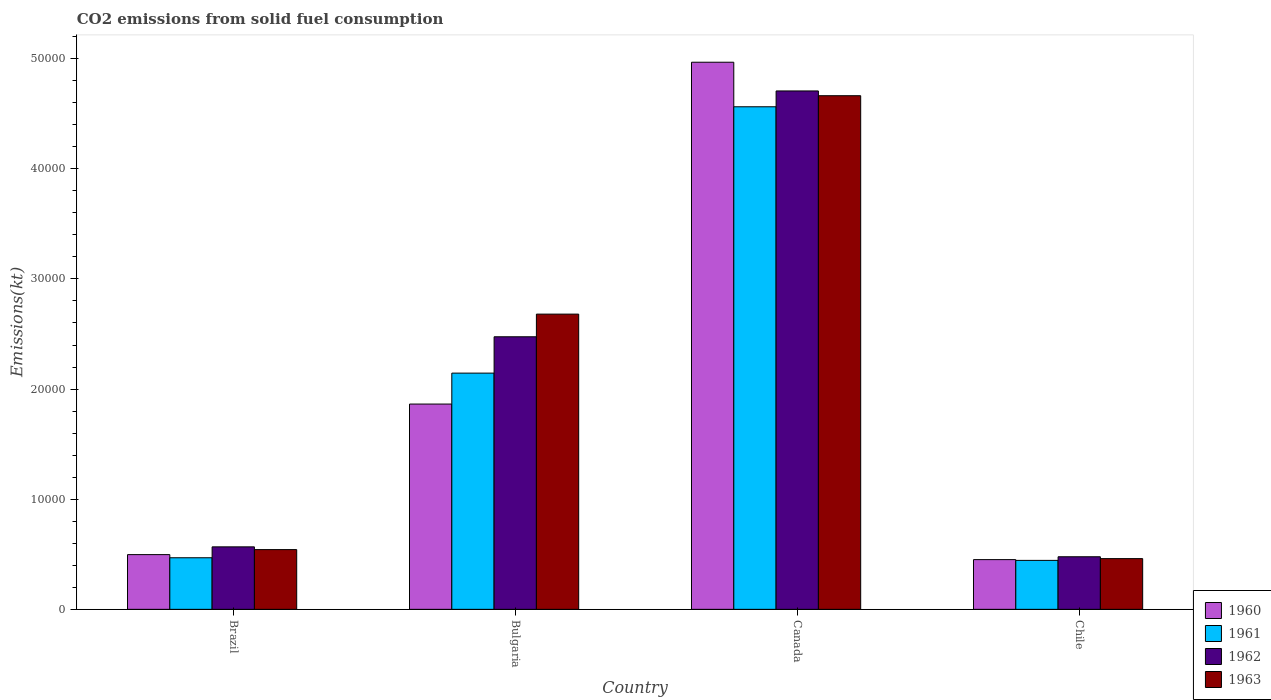Are the number of bars on each tick of the X-axis equal?
Keep it short and to the point. Yes. How many bars are there on the 4th tick from the right?
Your response must be concise. 4. What is the amount of CO2 emitted in 1960 in Canada?
Offer a terse response. 4.97e+04. Across all countries, what is the maximum amount of CO2 emitted in 1962?
Your answer should be very brief. 4.71e+04. Across all countries, what is the minimum amount of CO2 emitted in 1960?
Make the answer very short. 4514.08. In which country was the amount of CO2 emitted in 1961 maximum?
Ensure brevity in your answer.  Canada. In which country was the amount of CO2 emitted in 1962 minimum?
Provide a short and direct response. Chile. What is the total amount of CO2 emitted in 1960 in the graph?
Your response must be concise. 7.78e+04. What is the difference between the amount of CO2 emitted in 1961 in Brazil and that in Bulgaria?
Offer a terse response. -1.68e+04. What is the difference between the amount of CO2 emitted in 1962 in Canada and the amount of CO2 emitted in 1961 in Brazil?
Provide a short and direct response. 4.24e+04. What is the average amount of CO2 emitted in 1962 per country?
Your response must be concise. 2.06e+04. What is the difference between the amount of CO2 emitted of/in 1960 and amount of CO2 emitted of/in 1962 in Brazil?
Provide a short and direct response. -704.06. In how many countries, is the amount of CO2 emitted in 1963 greater than 38000 kt?
Your answer should be very brief. 1. What is the ratio of the amount of CO2 emitted in 1963 in Bulgaria to that in Canada?
Ensure brevity in your answer.  0.57. Is the amount of CO2 emitted in 1963 in Bulgaria less than that in Canada?
Provide a short and direct response. Yes. Is the difference between the amount of CO2 emitted in 1960 in Bulgaria and Chile greater than the difference between the amount of CO2 emitted in 1962 in Bulgaria and Chile?
Offer a terse response. No. What is the difference between the highest and the second highest amount of CO2 emitted in 1963?
Your response must be concise. 1.98e+04. What is the difference between the highest and the lowest amount of CO2 emitted in 1962?
Offer a very short reply. 4.23e+04. Is the sum of the amount of CO2 emitted in 1963 in Brazil and Bulgaria greater than the maximum amount of CO2 emitted in 1962 across all countries?
Your answer should be very brief. No. Is it the case that in every country, the sum of the amount of CO2 emitted in 1963 and amount of CO2 emitted in 1961 is greater than the sum of amount of CO2 emitted in 1962 and amount of CO2 emitted in 1960?
Keep it short and to the point. No. What does the 4th bar from the right in Brazil represents?
Keep it short and to the point. 1960. Is it the case that in every country, the sum of the amount of CO2 emitted in 1962 and amount of CO2 emitted in 1963 is greater than the amount of CO2 emitted in 1961?
Your answer should be compact. Yes. Are all the bars in the graph horizontal?
Provide a short and direct response. No. How many countries are there in the graph?
Your answer should be very brief. 4. What is the difference between two consecutive major ticks on the Y-axis?
Ensure brevity in your answer.  10000. Does the graph contain any zero values?
Keep it short and to the point. No. Where does the legend appear in the graph?
Give a very brief answer. Bottom right. How many legend labels are there?
Your answer should be compact. 4. How are the legend labels stacked?
Your response must be concise. Vertical. What is the title of the graph?
Make the answer very short. CO2 emissions from solid fuel consumption. Does "2006" appear as one of the legend labels in the graph?
Your answer should be very brief. No. What is the label or title of the X-axis?
Offer a very short reply. Country. What is the label or title of the Y-axis?
Provide a short and direct response. Emissions(kt). What is the Emissions(kt) of 1960 in Brazil?
Your answer should be very brief. 4968.78. What is the Emissions(kt) of 1961 in Brazil?
Offer a very short reply. 4682.76. What is the Emissions(kt) in 1962 in Brazil?
Keep it short and to the point. 5672.85. What is the Emissions(kt) in 1963 in Brazil?
Your answer should be very brief. 5423.49. What is the Emissions(kt) in 1960 in Bulgaria?
Your answer should be compact. 1.86e+04. What is the Emissions(kt) in 1961 in Bulgaria?
Ensure brevity in your answer.  2.14e+04. What is the Emissions(kt) of 1962 in Bulgaria?
Offer a terse response. 2.47e+04. What is the Emissions(kt) of 1963 in Bulgaria?
Provide a succinct answer. 2.68e+04. What is the Emissions(kt) in 1960 in Canada?
Offer a very short reply. 4.97e+04. What is the Emissions(kt) in 1961 in Canada?
Offer a terse response. 4.56e+04. What is the Emissions(kt) in 1962 in Canada?
Your answer should be compact. 4.71e+04. What is the Emissions(kt) in 1963 in Canada?
Ensure brevity in your answer.  4.66e+04. What is the Emissions(kt) of 1960 in Chile?
Provide a succinct answer. 4514.08. What is the Emissions(kt) in 1961 in Chile?
Keep it short and to the point. 4444.4. What is the Emissions(kt) in 1962 in Chile?
Your answer should be compact. 4774.43. What is the Emissions(kt) of 1963 in Chile?
Your response must be concise. 4605.75. Across all countries, what is the maximum Emissions(kt) of 1960?
Your response must be concise. 4.97e+04. Across all countries, what is the maximum Emissions(kt) in 1961?
Make the answer very short. 4.56e+04. Across all countries, what is the maximum Emissions(kt) in 1962?
Ensure brevity in your answer.  4.71e+04. Across all countries, what is the maximum Emissions(kt) in 1963?
Keep it short and to the point. 4.66e+04. Across all countries, what is the minimum Emissions(kt) of 1960?
Your answer should be very brief. 4514.08. Across all countries, what is the minimum Emissions(kt) of 1961?
Provide a short and direct response. 4444.4. Across all countries, what is the minimum Emissions(kt) in 1962?
Keep it short and to the point. 4774.43. Across all countries, what is the minimum Emissions(kt) in 1963?
Offer a very short reply. 4605.75. What is the total Emissions(kt) of 1960 in the graph?
Make the answer very short. 7.78e+04. What is the total Emissions(kt) of 1961 in the graph?
Provide a short and direct response. 7.62e+04. What is the total Emissions(kt) in 1962 in the graph?
Offer a very short reply. 8.23e+04. What is the total Emissions(kt) in 1963 in the graph?
Provide a succinct answer. 8.35e+04. What is the difference between the Emissions(kt) of 1960 in Brazil and that in Bulgaria?
Offer a terse response. -1.37e+04. What is the difference between the Emissions(kt) of 1961 in Brazil and that in Bulgaria?
Ensure brevity in your answer.  -1.68e+04. What is the difference between the Emissions(kt) in 1962 in Brazil and that in Bulgaria?
Make the answer very short. -1.91e+04. What is the difference between the Emissions(kt) of 1963 in Brazil and that in Bulgaria?
Offer a terse response. -2.14e+04. What is the difference between the Emissions(kt) in 1960 in Brazil and that in Canada?
Offer a very short reply. -4.47e+04. What is the difference between the Emissions(kt) in 1961 in Brazil and that in Canada?
Your answer should be compact. -4.09e+04. What is the difference between the Emissions(kt) of 1962 in Brazil and that in Canada?
Your answer should be very brief. -4.14e+04. What is the difference between the Emissions(kt) in 1963 in Brazil and that in Canada?
Give a very brief answer. -4.12e+04. What is the difference between the Emissions(kt) in 1960 in Brazil and that in Chile?
Offer a very short reply. 454.71. What is the difference between the Emissions(kt) in 1961 in Brazil and that in Chile?
Offer a very short reply. 238.35. What is the difference between the Emissions(kt) in 1962 in Brazil and that in Chile?
Your response must be concise. 898.41. What is the difference between the Emissions(kt) of 1963 in Brazil and that in Chile?
Keep it short and to the point. 817.74. What is the difference between the Emissions(kt) in 1960 in Bulgaria and that in Canada?
Offer a terse response. -3.10e+04. What is the difference between the Emissions(kt) in 1961 in Bulgaria and that in Canada?
Keep it short and to the point. -2.42e+04. What is the difference between the Emissions(kt) of 1962 in Bulgaria and that in Canada?
Ensure brevity in your answer.  -2.23e+04. What is the difference between the Emissions(kt) of 1963 in Bulgaria and that in Canada?
Your answer should be compact. -1.98e+04. What is the difference between the Emissions(kt) in 1960 in Bulgaria and that in Chile?
Provide a short and direct response. 1.41e+04. What is the difference between the Emissions(kt) of 1961 in Bulgaria and that in Chile?
Give a very brief answer. 1.70e+04. What is the difference between the Emissions(kt) of 1962 in Bulgaria and that in Chile?
Provide a short and direct response. 2.00e+04. What is the difference between the Emissions(kt) in 1963 in Bulgaria and that in Chile?
Keep it short and to the point. 2.22e+04. What is the difference between the Emissions(kt) in 1960 in Canada and that in Chile?
Make the answer very short. 4.52e+04. What is the difference between the Emissions(kt) in 1961 in Canada and that in Chile?
Offer a terse response. 4.12e+04. What is the difference between the Emissions(kt) of 1962 in Canada and that in Chile?
Give a very brief answer. 4.23e+04. What is the difference between the Emissions(kt) of 1963 in Canada and that in Chile?
Provide a short and direct response. 4.20e+04. What is the difference between the Emissions(kt) of 1960 in Brazil and the Emissions(kt) of 1961 in Bulgaria?
Your answer should be very brief. -1.65e+04. What is the difference between the Emissions(kt) in 1960 in Brazil and the Emissions(kt) in 1962 in Bulgaria?
Ensure brevity in your answer.  -1.98e+04. What is the difference between the Emissions(kt) in 1960 in Brazil and the Emissions(kt) in 1963 in Bulgaria?
Your answer should be very brief. -2.18e+04. What is the difference between the Emissions(kt) in 1961 in Brazil and the Emissions(kt) in 1962 in Bulgaria?
Your answer should be compact. -2.01e+04. What is the difference between the Emissions(kt) in 1961 in Brazil and the Emissions(kt) in 1963 in Bulgaria?
Your answer should be compact. -2.21e+04. What is the difference between the Emissions(kt) in 1962 in Brazil and the Emissions(kt) in 1963 in Bulgaria?
Your response must be concise. -2.11e+04. What is the difference between the Emissions(kt) of 1960 in Brazil and the Emissions(kt) of 1961 in Canada?
Your answer should be compact. -4.07e+04. What is the difference between the Emissions(kt) of 1960 in Brazil and the Emissions(kt) of 1962 in Canada?
Offer a very short reply. -4.21e+04. What is the difference between the Emissions(kt) in 1960 in Brazil and the Emissions(kt) in 1963 in Canada?
Offer a very short reply. -4.17e+04. What is the difference between the Emissions(kt) of 1961 in Brazil and the Emissions(kt) of 1962 in Canada?
Your answer should be compact. -4.24e+04. What is the difference between the Emissions(kt) of 1961 in Brazil and the Emissions(kt) of 1963 in Canada?
Provide a succinct answer. -4.20e+04. What is the difference between the Emissions(kt) in 1962 in Brazil and the Emissions(kt) in 1963 in Canada?
Provide a succinct answer. -4.10e+04. What is the difference between the Emissions(kt) of 1960 in Brazil and the Emissions(kt) of 1961 in Chile?
Your answer should be very brief. 524.38. What is the difference between the Emissions(kt) in 1960 in Brazil and the Emissions(kt) in 1962 in Chile?
Ensure brevity in your answer.  194.35. What is the difference between the Emissions(kt) in 1960 in Brazil and the Emissions(kt) in 1963 in Chile?
Offer a very short reply. 363.03. What is the difference between the Emissions(kt) in 1961 in Brazil and the Emissions(kt) in 1962 in Chile?
Give a very brief answer. -91.67. What is the difference between the Emissions(kt) in 1961 in Brazil and the Emissions(kt) in 1963 in Chile?
Your answer should be very brief. 77.01. What is the difference between the Emissions(kt) in 1962 in Brazil and the Emissions(kt) in 1963 in Chile?
Your answer should be compact. 1067.1. What is the difference between the Emissions(kt) in 1960 in Bulgaria and the Emissions(kt) in 1961 in Canada?
Offer a terse response. -2.70e+04. What is the difference between the Emissions(kt) in 1960 in Bulgaria and the Emissions(kt) in 1962 in Canada?
Keep it short and to the point. -2.84e+04. What is the difference between the Emissions(kt) in 1960 in Bulgaria and the Emissions(kt) in 1963 in Canada?
Your answer should be compact. -2.80e+04. What is the difference between the Emissions(kt) in 1961 in Bulgaria and the Emissions(kt) in 1962 in Canada?
Your response must be concise. -2.56e+04. What is the difference between the Emissions(kt) of 1961 in Bulgaria and the Emissions(kt) of 1963 in Canada?
Your response must be concise. -2.52e+04. What is the difference between the Emissions(kt) in 1962 in Bulgaria and the Emissions(kt) in 1963 in Canada?
Offer a terse response. -2.19e+04. What is the difference between the Emissions(kt) in 1960 in Bulgaria and the Emissions(kt) in 1961 in Chile?
Give a very brief answer. 1.42e+04. What is the difference between the Emissions(kt) of 1960 in Bulgaria and the Emissions(kt) of 1962 in Chile?
Give a very brief answer. 1.39e+04. What is the difference between the Emissions(kt) in 1960 in Bulgaria and the Emissions(kt) in 1963 in Chile?
Your response must be concise. 1.40e+04. What is the difference between the Emissions(kt) of 1961 in Bulgaria and the Emissions(kt) of 1962 in Chile?
Ensure brevity in your answer.  1.67e+04. What is the difference between the Emissions(kt) of 1961 in Bulgaria and the Emissions(kt) of 1963 in Chile?
Your answer should be compact. 1.68e+04. What is the difference between the Emissions(kt) in 1962 in Bulgaria and the Emissions(kt) in 1963 in Chile?
Offer a very short reply. 2.01e+04. What is the difference between the Emissions(kt) of 1960 in Canada and the Emissions(kt) of 1961 in Chile?
Ensure brevity in your answer.  4.52e+04. What is the difference between the Emissions(kt) in 1960 in Canada and the Emissions(kt) in 1962 in Chile?
Ensure brevity in your answer.  4.49e+04. What is the difference between the Emissions(kt) of 1960 in Canada and the Emissions(kt) of 1963 in Chile?
Provide a succinct answer. 4.51e+04. What is the difference between the Emissions(kt) in 1961 in Canada and the Emissions(kt) in 1962 in Chile?
Offer a terse response. 4.09e+04. What is the difference between the Emissions(kt) in 1961 in Canada and the Emissions(kt) in 1963 in Chile?
Make the answer very short. 4.10e+04. What is the difference between the Emissions(kt) of 1962 in Canada and the Emissions(kt) of 1963 in Chile?
Offer a very short reply. 4.25e+04. What is the average Emissions(kt) in 1960 per country?
Ensure brevity in your answer.  1.94e+04. What is the average Emissions(kt) in 1961 per country?
Offer a terse response. 1.91e+04. What is the average Emissions(kt) in 1962 per country?
Your response must be concise. 2.06e+04. What is the average Emissions(kt) of 1963 per country?
Offer a very short reply. 2.09e+04. What is the difference between the Emissions(kt) in 1960 and Emissions(kt) in 1961 in Brazil?
Your response must be concise. 286.03. What is the difference between the Emissions(kt) in 1960 and Emissions(kt) in 1962 in Brazil?
Give a very brief answer. -704.06. What is the difference between the Emissions(kt) in 1960 and Emissions(kt) in 1963 in Brazil?
Your answer should be compact. -454.71. What is the difference between the Emissions(kt) of 1961 and Emissions(kt) of 1962 in Brazil?
Make the answer very short. -990.09. What is the difference between the Emissions(kt) in 1961 and Emissions(kt) in 1963 in Brazil?
Offer a terse response. -740.73. What is the difference between the Emissions(kt) of 1962 and Emissions(kt) of 1963 in Brazil?
Your answer should be very brief. 249.36. What is the difference between the Emissions(kt) of 1960 and Emissions(kt) of 1961 in Bulgaria?
Your answer should be very brief. -2808.92. What is the difference between the Emissions(kt) of 1960 and Emissions(kt) of 1962 in Bulgaria?
Your answer should be compact. -6109.22. What is the difference between the Emissions(kt) in 1960 and Emissions(kt) in 1963 in Bulgaria?
Provide a succinct answer. -8166.41. What is the difference between the Emissions(kt) of 1961 and Emissions(kt) of 1962 in Bulgaria?
Make the answer very short. -3300.3. What is the difference between the Emissions(kt) in 1961 and Emissions(kt) in 1963 in Bulgaria?
Ensure brevity in your answer.  -5357.49. What is the difference between the Emissions(kt) of 1962 and Emissions(kt) of 1963 in Bulgaria?
Your response must be concise. -2057.19. What is the difference between the Emissions(kt) in 1960 and Emissions(kt) in 1961 in Canada?
Keep it short and to the point. 4044.7. What is the difference between the Emissions(kt) of 1960 and Emissions(kt) of 1962 in Canada?
Ensure brevity in your answer.  2607.24. What is the difference between the Emissions(kt) in 1960 and Emissions(kt) in 1963 in Canada?
Offer a very short reply. 3039.94. What is the difference between the Emissions(kt) of 1961 and Emissions(kt) of 1962 in Canada?
Offer a very short reply. -1437.46. What is the difference between the Emissions(kt) in 1961 and Emissions(kt) in 1963 in Canada?
Ensure brevity in your answer.  -1004.76. What is the difference between the Emissions(kt) of 1962 and Emissions(kt) of 1963 in Canada?
Offer a terse response. 432.71. What is the difference between the Emissions(kt) of 1960 and Emissions(kt) of 1961 in Chile?
Your answer should be very brief. 69.67. What is the difference between the Emissions(kt) of 1960 and Emissions(kt) of 1962 in Chile?
Your answer should be very brief. -260.36. What is the difference between the Emissions(kt) of 1960 and Emissions(kt) of 1963 in Chile?
Provide a succinct answer. -91.67. What is the difference between the Emissions(kt) in 1961 and Emissions(kt) in 1962 in Chile?
Your response must be concise. -330.03. What is the difference between the Emissions(kt) of 1961 and Emissions(kt) of 1963 in Chile?
Keep it short and to the point. -161.35. What is the difference between the Emissions(kt) of 1962 and Emissions(kt) of 1963 in Chile?
Your answer should be very brief. 168.68. What is the ratio of the Emissions(kt) of 1960 in Brazil to that in Bulgaria?
Offer a terse response. 0.27. What is the ratio of the Emissions(kt) in 1961 in Brazil to that in Bulgaria?
Offer a very short reply. 0.22. What is the ratio of the Emissions(kt) in 1962 in Brazil to that in Bulgaria?
Give a very brief answer. 0.23. What is the ratio of the Emissions(kt) of 1963 in Brazil to that in Bulgaria?
Make the answer very short. 0.2. What is the ratio of the Emissions(kt) of 1961 in Brazil to that in Canada?
Provide a short and direct response. 0.1. What is the ratio of the Emissions(kt) of 1962 in Brazil to that in Canada?
Your response must be concise. 0.12. What is the ratio of the Emissions(kt) in 1963 in Brazil to that in Canada?
Give a very brief answer. 0.12. What is the ratio of the Emissions(kt) in 1960 in Brazil to that in Chile?
Ensure brevity in your answer.  1.1. What is the ratio of the Emissions(kt) of 1961 in Brazil to that in Chile?
Provide a short and direct response. 1.05. What is the ratio of the Emissions(kt) of 1962 in Brazil to that in Chile?
Offer a very short reply. 1.19. What is the ratio of the Emissions(kt) in 1963 in Brazil to that in Chile?
Your response must be concise. 1.18. What is the ratio of the Emissions(kt) of 1960 in Bulgaria to that in Canada?
Keep it short and to the point. 0.38. What is the ratio of the Emissions(kt) of 1961 in Bulgaria to that in Canada?
Give a very brief answer. 0.47. What is the ratio of the Emissions(kt) of 1962 in Bulgaria to that in Canada?
Provide a succinct answer. 0.53. What is the ratio of the Emissions(kt) of 1963 in Bulgaria to that in Canada?
Keep it short and to the point. 0.57. What is the ratio of the Emissions(kt) of 1960 in Bulgaria to that in Chile?
Keep it short and to the point. 4.13. What is the ratio of the Emissions(kt) of 1961 in Bulgaria to that in Chile?
Your response must be concise. 4.83. What is the ratio of the Emissions(kt) of 1962 in Bulgaria to that in Chile?
Your answer should be compact. 5.18. What is the ratio of the Emissions(kt) of 1963 in Bulgaria to that in Chile?
Offer a terse response. 5.82. What is the ratio of the Emissions(kt) in 1960 in Canada to that in Chile?
Keep it short and to the point. 11. What is the ratio of the Emissions(kt) in 1961 in Canada to that in Chile?
Make the answer very short. 10.27. What is the ratio of the Emissions(kt) in 1962 in Canada to that in Chile?
Provide a succinct answer. 9.86. What is the ratio of the Emissions(kt) of 1963 in Canada to that in Chile?
Your answer should be very brief. 10.13. What is the difference between the highest and the second highest Emissions(kt) in 1960?
Make the answer very short. 3.10e+04. What is the difference between the highest and the second highest Emissions(kt) in 1961?
Keep it short and to the point. 2.42e+04. What is the difference between the highest and the second highest Emissions(kt) in 1962?
Offer a terse response. 2.23e+04. What is the difference between the highest and the second highest Emissions(kt) of 1963?
Offer a very short reply. 1.98e+04. What is the difference between the highest and the lowest Emissions(kt) in 1960?
Provide a short and direct response. 4.52e+04. What is the difference between the highest and the lowest Emissions(kt) of 1961?
Offer a very short reply. 4.12e+04. What is the difference between the highest and the lowest Emissions(kt) in 1962?
Ensure brevity in your answer.  4.23e+04. What is the difference between the highest and the lowest Emissions(kt) of 1963?
Give a very brief answer. 4.20e+04. 